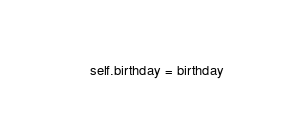Convert code to text. <code><loc_0><loc_0><loc_500><loc_500><_Python_>        self.birthday = birthday


</code> 